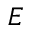<formula> <loc_0><loc_0><loc_500><loc_500>E</formula> 